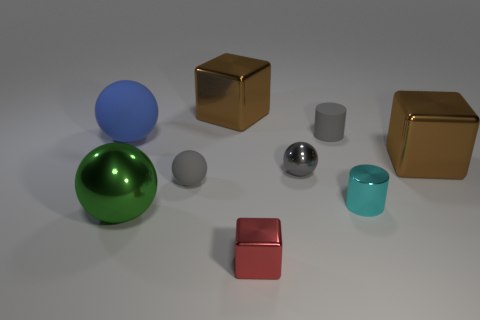How many objects are depicted, and can you categorize them by shape and color? In the image, there are a total of eight objects which can be categorized by shape and color as follows: One large green sphere, one medium-sized blue sphere, one small gray sphere, two cubes - one small red and one large brown, one small shiny silver cylinder, one large matte gray cylinder, and one cyan cylinder. 